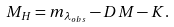Convert formula to latex. <formula><loc_0><loc_0><loc_500><loc_500>M _ { H } = m _ { \lambda _ { o b s } } - D M - K .</formula> 